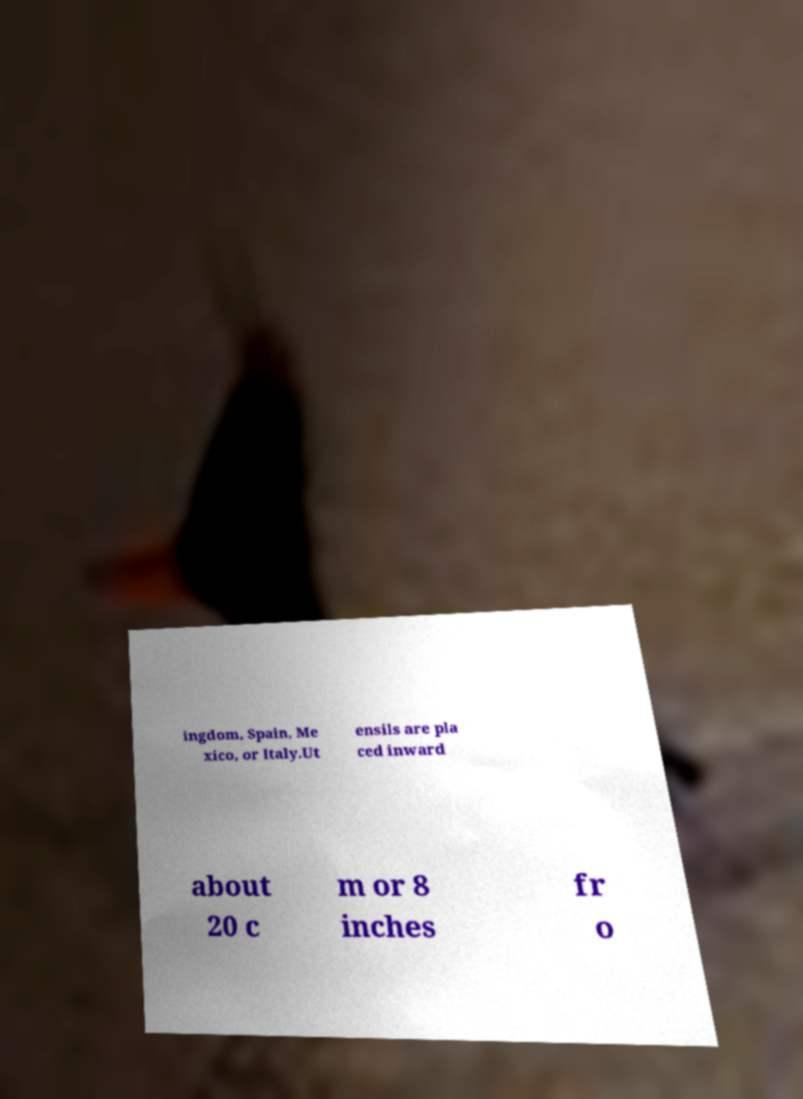I need the written content from this picture converted into text. Can you do that? ingdom, Spain, Me xico, or Italy.Ut ensils are pla ced inward about 20 c m or 8 inches fr o 